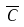<formula> <loc_0><loc_0><loc_500><loc_500>\overline { C }</formula> 